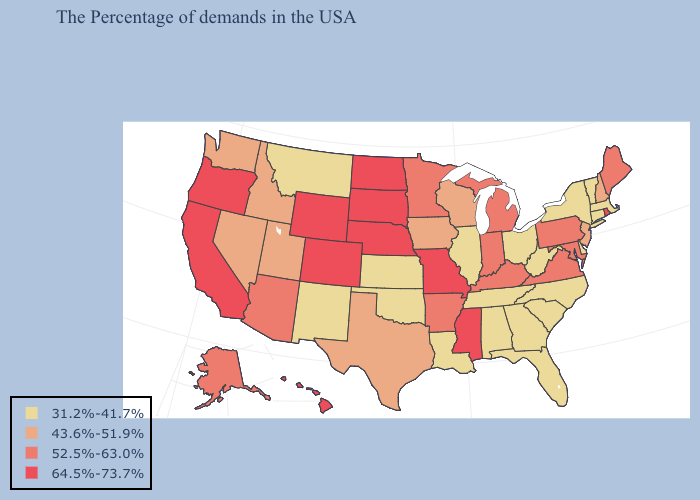Does Rhode Island have a lower value than Oklahoma?
Write a very short answer. No. What is the lowest value in states that border Kentucky?
Write a very short answer. 31.2%-41.7%. Does the first symbol in the legend represent the smallest category?
Short answer required. Yes. Which states have the highest value in the USA?
Give a very brief answer. Rhode Island, Mississippi, Missouri, Nebraska, South Dakota, North Dakota, Wyoming, Colorado, California, Oregon, Hawaii. Name the states that have a value in the range 64.5%-73.7%?
Quick response, please. Rhode Island, Mississippi, Missouri, Nebraska, South Dakota, North Dakota, Wyoming, Colorado, California, Oregon, Hawaii. What is the highest value in the USA?
Quick response, please. 64.5%-73.7%. Name the states that have a value in the range 31.2%-41.7%?
Write a very short answer. Massachusetts, Vermont, Connecticut, New York, Delaware, North Carolina, South Carolina, West Virginia, Ohio, Florida, Georgia, Alabama, Tennessee, Illinois, Louisiana, Kansas, Oklahoma, New Mexico, Montana. Is the legend a continuous bar?
Short answer required. No. What is the value of New Jersey?
Short answer required. 43.6%-51.9%. Does Colorado have a lower value than Vermont?
Concise answer only. No. Does the map have missing data?
Give a very brief answer. No. What is the highest value in states that border Vermont?
Keep it brief. 43.6%-51.9%. Name the states that have a value in the range 52.5%-63.0%?
Concise answer only. Maine, Maryland, Pennsylvania, Virginia, Michigan, Kentucky, Indiana, Arkansas, Minnesota, Arizona, Alaska. Among the states that border Michigan , which have the highest value?
Answer briefly. Indiana. 